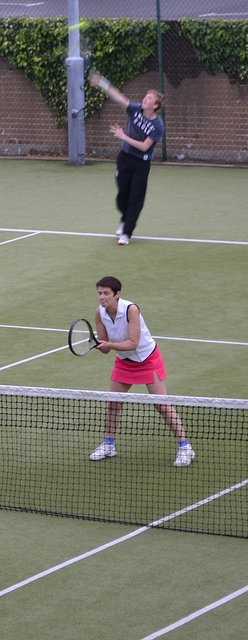Describe the objects in this image and their specific colors. I can see people in gray, darkgray, and lavender tones, people in gray, black, navy, and darkgray tones, tennis racket in gray, darkgray, black, and lavender tones, and sports ball in gray, darkgray, and beige tones in this image. 